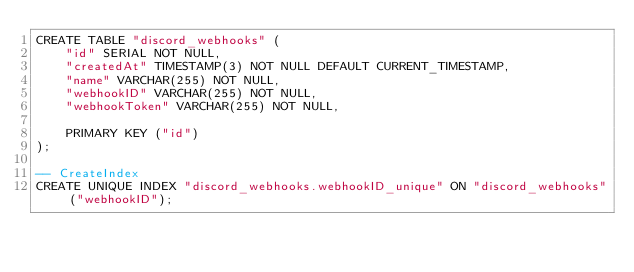Convert code to text. <code><loc_0><loc_0><loc_500><loc_500><_SQL_>CREATE TABLE "discord_webhooks" (
    "id" SERIAL NOT NULL,
    "createdAt" TIMESTAMP(3) NOT NULL DEFAULT CURRENT_TIMESTAMP,
    "name" VARCHAR(255) NOT NULL,
    "webhookID" VARCHAR(255) NOT NULL,
    "webhookToken" VARCHAR(255) NOT NULL,

    PRIMARY KEY ("id")
);

-- CreateIndex
CREATE UNIQUE INDEX "discord_webhooks.webhookID_unique" ON "discord_webhooks"("webhookID");
</code> 